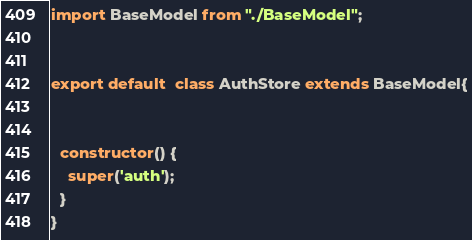Convert code to text. <code><loc_0><loc_0><loc_500><loc_500><_JavaScript_>
import BaseModel from "./BaseModel";


export default  class AuthStore extends BaseModel{
 

  constructor() {
    super('auth');
  }
}
</code> 